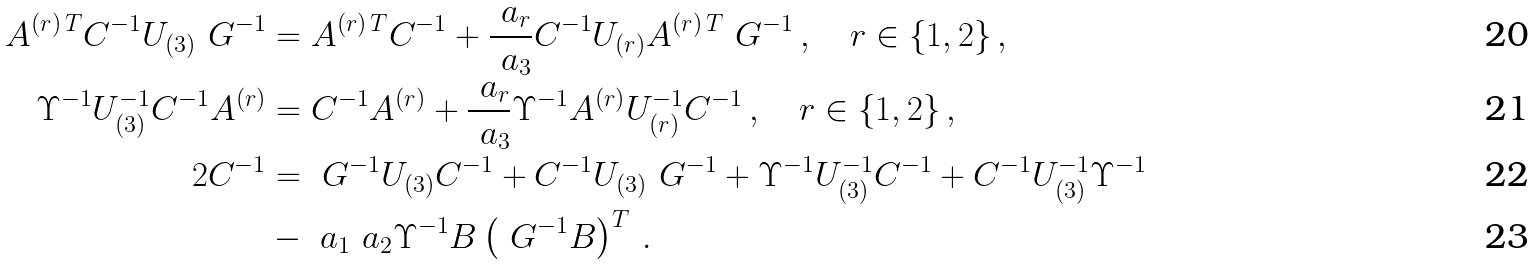<formula> <loc_0><loc_0><loc_500><loc_500>A ^ { ( r ) \, T } C ^ { - 1 } U _ { ( 3 ) } \ G ^ { - 1 } & = A ^ { ( r ) \, T } C ^ { - 1 } + \frac { \ a _ { r } } { \ a _ { 3 } } C ^ { - 1 } U _ { ( r ) } A ^ { ( r ) \, T } \ G ^ { - 1 } \, , \quad r \in \{ 1 , 2 \} \, , \\ \Upsilon ^ { - 1 } U _ { ( 3 ) } ^ { - 1 } C ^ { - 1 } A ^ { ( r ) } & = C ^ { - 1 } A ^ { ( r ) } + \frac { \ a _ { r } } { \ a _ { 3 } } \Upsilon ^ { - 1 } A ^ { ( r ) } U _ { ( r ) } ^ { - 1 } C ^ { - 1 } \, , \quad r \in \{ 1 , 2 \} \, , \\ 2 C ^ { - 1 } & = \ G ^ { - 1 } U _ { ( 3 ) } C ^ { - 1 } + C ^ { - 1 } U _ { ( 3 ) } \ G ^ { - 1 } + \Upsilon ^ { - 1 } U _ { ( 3 ) } ^ { - 1 } C ^ { - 1 } + C ^ { - 1 } U _ { ( 3 ) } ^ { - 1 } \Upsilon ^ { - 1 } \\ & - \ a _ { 1 } \ a _ { 2 } \Upsilon ^ { - 1 } B \left ( \ G ^ { - 1 } B \right ) ^ { T } \, .</formula> 